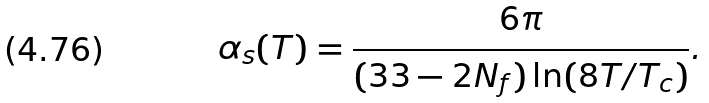<formula> <loc_0><loc_0><loc_500><loc_500>\alpha _ { s } ( T ) = \frac { 6 \pi } { ( 3 3 - 2 N _ { f } ) \ln ( 8 T / T _ { c } ) } .</formula> 